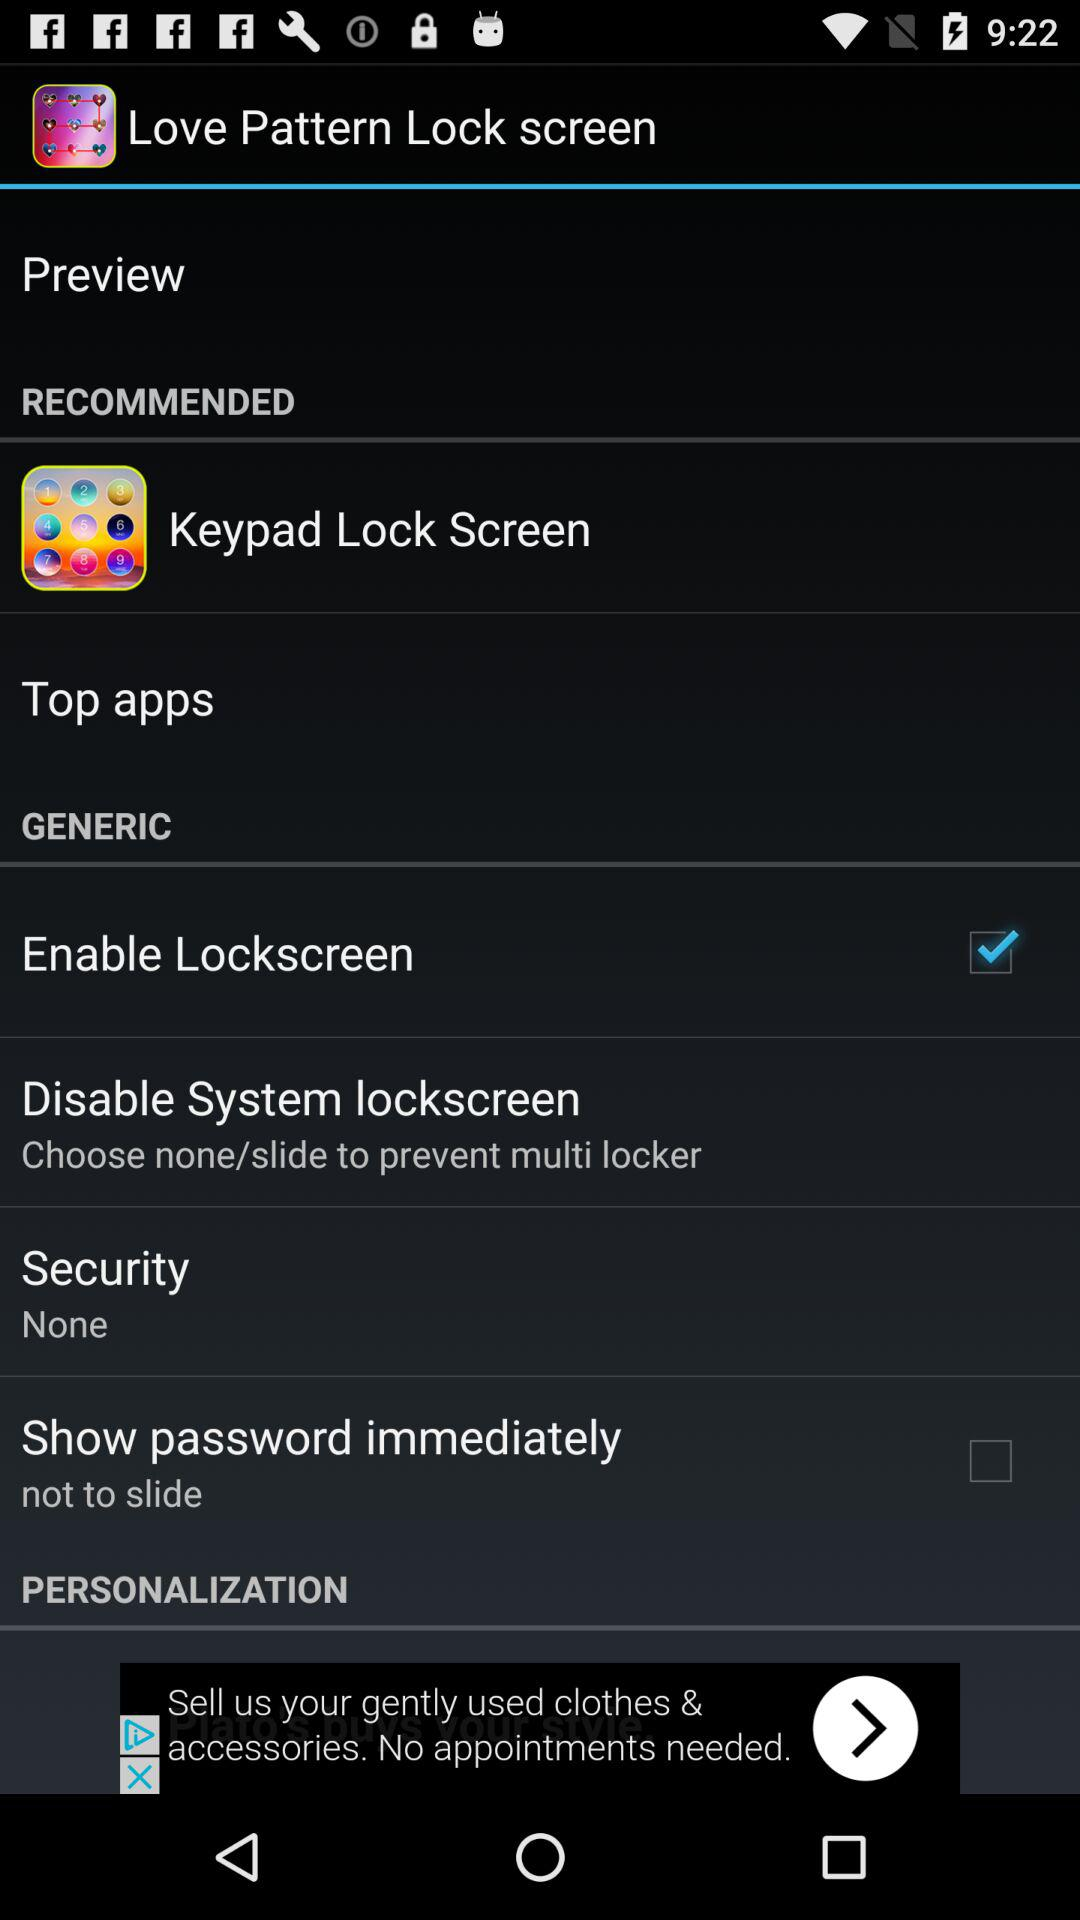What's the status of "Enable Lockscreen"? The status is "on". 